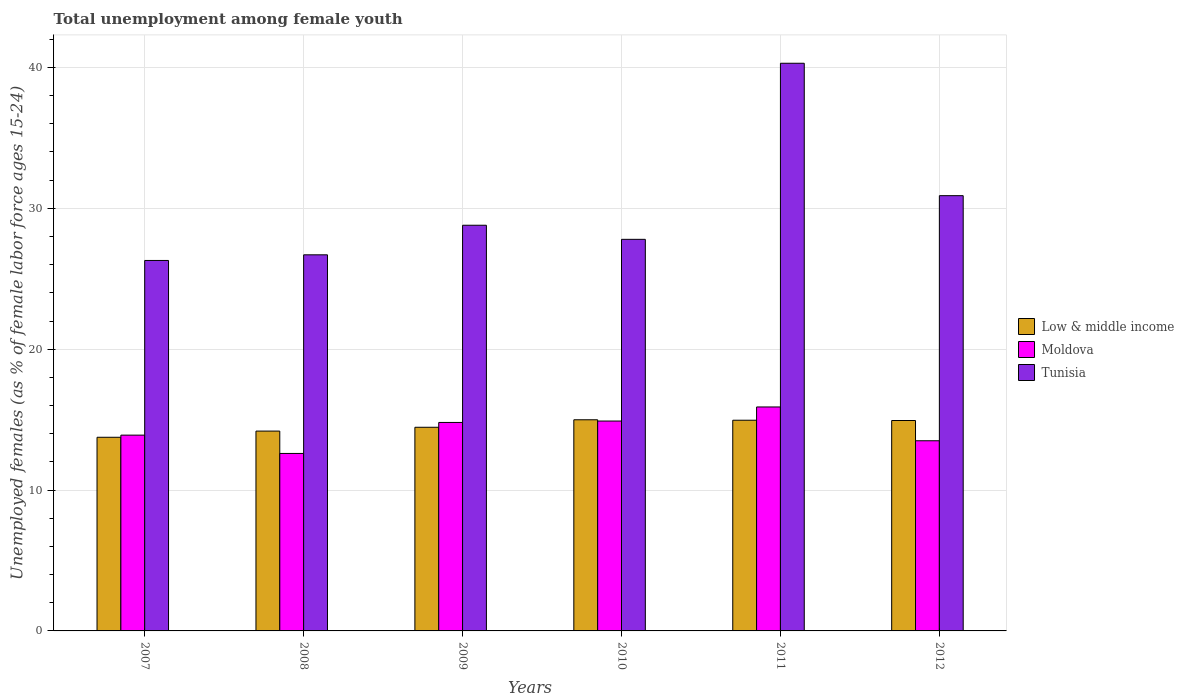How many different coloured bars are there?
Give a very brief answer. 3. How many bars are there on the 6th tick from the right?
Give a very brief answer. 3. What is the percentage of unemployed females in in Low & middle income in 2007?
Provide a short and direct response. 13.75. Across all years, what is the maximum percentage of unemployed females in in Tunisia?
Provide a short and direct response. 40.3. Across all years, what is the minimum percentage of unemployed females in in Low & middle income?
Offer a terse response. 13.75. In which year was the percentage of unemployed females in in Moldova maximum?
Offer a very short reply. 2011. What is the total percentage of unemployed females in in Low & middle income in the graph?
Provide a short and direct response. 87.28. What is the difference between the percentage of unemployed females in in Low & middle income in 2008 and that in 2010?
Keep it short and to the point. -0.8. What is the difference between the percentage of unemployed females in in Moldova in 2011 and the percentage of unemployed females in in Low & middle income in 2010?
Keep it short and to the point. 0.91. What is the average percentage of unemployed females in in Low & middle income per year?
Your answer should be compact. 14.55. In the year 2011, what is the difference between the percentage of unemployed females in in Low & middle income and percentage of unemployed females in in Tunisia?
Keep it short and to the point. -25.34. In how many years, is the percentage of unemployed females in in Low & middle income greater than 10 %?
Offer a terse response. 6. What is the ratio of the percentage of unemployed females in in Low & middle income in 2010 to that in 2011?
Give a very brief answer. 1. Is the difference between the percentage of unemployed females in in Low & middle income in 2009 and 2011 greater than the difference between the percentage of unemployed females in in Tunisia in 2009 and 2011?
Provide a succinct answer. Yes. What is the difference between the highest and the second highest percentage of unemployed females in in Tunisia?
Offer a terse response. 9.4. What is the difference between the highest and the lowest percentage of unemployed females in in Tunisia?
Offer a terse response. 14. In how many years, is the percentage of unemployed females in in Moldova greater than the average percentage of unemployed females in in Moldova taken over all years?
Provide a succinct answer. 3. Is the sum of the percentage of unemployed females in in Moldova in 2009 and 2011 greater than the maximum percentage of unemployed females in in Tunisia across all years?
Provide a succinct answer. No. What does the 3rd bar from the left in 2009 represents?
Keep it short and to the point. Tunisia. What does the 2nd bar from the right in 2012 represents?
Your answer should be very brief. Moldova. Is it the case that in every year, the sum of the percentage of unemployed females in in Low & middle income and percentage of unemployed females in in Tunisia is greater than the percentage of unemployed females in in Moldova?
Your response must be concise. Yes. How many years are there in the graph?
Make the answer very short. 6. Does the graph contain any zero values?
Offer a very short reply. No. Does the graph contain grids?
Offer a very short reply. Yes. What is the title of the graph?
Give a very brief answer. Total unemployment among female youth. Does "High income" appear as one of the legend labels in the graph?
Provide a succinct answer. No. What is the label or title of the X-axis?
Make the answer very short. Years. What is the label or title of the Y-axis?
Offer a terse response. Unemployed females (as % of female labor force ages 15-24). What is the Unemployed females (as % of female labor force ages 15-24) of Low & middle income in 2007?
Offer a terse response. 13.75. What is the Unemployed females (as % of female labor force ages 15-24) of Moldova in 2007?
Your answer should be very brief. 13.9. What is the Unemployed females (as % of female labor force ages 15-24) in Tunisia in 2007?
Make the answer very short. 26.3. What is the Unemployed females (as % of female labor force ages 15-24) of Low & middle income in 2008?
Your answer should be very brief. 14.19. What is the Unemployed females (as % of female labor force ages 15-24) of Moldova in 2008?
Provide a short and direct response. 12.6. What is the Unemployed females (as % of female labor force ages 15-24) in Tunisia in 2008?
Give a very brief answer. 26.7. What is the Unemployed females (as % of female labor force ages 15-24) in Low & middle income in 2009?
Your answer should be very brief. 14.46. What is the Unemployed females (as % of female labor force ages 15-24) of Moldova in 2009?
Your response must be concise. 14.8. What is the Unemployed females (as % of female labor force ages 15-24) in Tunisia in 2009?
Provide a short and direct response. 28.8. What is the Unemployed females (as % of female labor force ages 15-24) of Low & middle income in 2010?
Provide a succinct answer. 14.99. What is the Unemployed females (as % of female labor force ages 15-24) in Moldova in 2010?
Give a very brief answer. 14.9. What is the Unemployed females (as % of female labor force ages 15-24) in Tunisia in 2010?
Your answer should be compact. 27.8. What is the Unemployed females (as % of female labor force ages 15-24) in Low & middle income in 2011?
Provide a short and direct response. 14.96. What is the Unemployed females (as % of female labor force ages 15-24) in Moldova in 2011?
Keep it short and to the point. 15.9. What is the Unemployed females (as % of female labor force ages 15-24) in Tunisia in 2011?
Give a very brief answer. 40.3. What is the Unemployed females (as % of female labor force ages 15-24) of Low & middle income in 2012?
Your response must be concise. 14.94. What is the Unemployed females (as % of female labor force ages 15-24) of Moldova in 2012?
Provide a short and direct response. 13.5. What is the Unemployed females (as % of female labor force ages 15-24) of Tunisia in 2012?
Offer a terse response. 30.9. Across all years, what is the maximum Unemployed females (as % of female labor force ages 15-24) of Low & middle income?
Ensure brevity in your answer.  14.99. Across all years, what is the maximum Unemployed females (as % of female labor force ages 15-24) of Moldova?
Make the answer very short. 15.9. Across all years, what is the maximum Unemployed females (as % of female labor force ages 15-24) of Tunisia?
Your response must be concise. 40.3. Across all years, what is the minimum Unemployed females (as % of female labor force ages 15-24) in Low & middle income?
Your response must be concise. 13.75. Across all years, what is the minimum Unemployed females (as % of female labor force ages 15-24) in Moldova?
Make the answer very short. 12.6. Across all years, what is the minimum Unemployed females (as % of female labor force ages 15-24) of Tunisia?
Your response must be concise. 26.3. What is the total Unemployed females (as % of female labor force ages 15-24) of Low & middle income in the graph?
Give a very brief answer. 87.28. What is the total Unemployed females (as % of female labor force ages 15-24) of Moldova in the graph?
Offer a terse response. 85.6. What is the total Unemployed females (as % of female labor force ages 15-24) of Tunisia in the graph?
Offer a terse response. 180.8. What is the difference between the Unemployed females (as % of female labor force ages 15-24) in Low & middle income in 2007 and that in 2008?
Give a very brief answer. -0.44. What is the difference between the Unemployed females (as % of female labor force ages 15-24) of Low & middle income in 2007 and that in 2009?
Keep it short and to the point. -0.71. What is the difference between the Unemployed females (as % of female labor force ages 15-24) in Moldova in 2007 and that in 2009?
Provide a succinct answer. -0.9. What is the difference between the Unemployed females (as % of female labor force ages 15-24) in Tunisia in 2007 and that in 2009?
Your response must be concise. -2.5. What is the difference between the Unemployed females (as % of female labor force ages 15-24) of Low & middle income in 2007 and that in 2010?
Provide a succinct answer. -1.24. What is the difference between the Unemployed females (as % of female labor force ages 15-24) in Moldova in 2007 and that in 2010?
Offer a terse response. -1. What is the difference between the Unemployed females (as % of female labor force ages 15-24) in Low & middle income in 2007 and that in 2011?
Keep it short and to the point. -1.21. What is the difference between the Unemployed females (as % of female labor force ages 15-24) in Moldova in 2007 and that in 2011?
Your answer should be very brief. -2. What is the difference between the Unemployed females (as % of female labor force ages 15-24) in Low & middle income in 2007 and that in 2012?
Your answer should be very brief. -1.19. What is the difference between the Unemployed females (as % of female labor force ages 15-24) of Tunisia in 2007 and that in 2012?
Make the answer very short. -4.6. What is the difference between the Unemployed females (as % of female labor force ages 15-24) of Low & middle income in 2008 and that in 2009?
Provide a succinct answer. -0.27. What is the difference between the Unemployed females (as % of female labor force ages 15-24) in Moldova in 2008 and that in 2009?
Provide a short and direct response. -2.2. What is the difference between the Unemployed females (as % of female labor force ages 15-24) in Tunisia in 2008 and that in 2009?
Provide a succinct answer. -2.1. What is the difference between the Unemployed females (as % of female labor force ages 15-24) of Low & middle income in 2008 and that in 2010?
Your response must be concise. -0.8. What is the difference between the Unemployed females (as % of female labor force ages 15-24) in Moldova in 2008 and that in 2010?
Your answer should be very brief. -2.3. What is the difference between the Unemployed females (as % of female labor force ages 15-24) of Low & middle income in 2008 and that in 2011?
Give a very brief answer. -0.77. What is the difference between the Unemployed females (as % of female labor force ages 15-24) of Moldova in 2008 and that in 2011?
Keep it short and to the point. -3.3. What is the difference between the Unemployed females (as % of female labor force ages 15-24) in Tunisia in 2008 and that in 2011?
Your answer should be very brief. -13.6. What is the difference between the Unemployed females (as % of female labor force ages 15-24) of Low & middle income in 2008 and that in 2012?
Your response must be concise. -0.75. What is the difference between the Unemployed females (as % of female labor force ages 15-24) in Low & middle income in 2009 and that in 2010?
Your response must be concise. -0.53. What is the difference between the Unemployed females (as % of female labor force ages 15-24) of Moldova in 2009 and that in 2010?
Provide a succinct answer. -0.1. What is the difference between the Unemployed females (as % of female labor force ages 15-24) of Low & middle income in 2009 and that in 2011?
Provide a short and direct response. -0.5. What is the difference between the Unemployed females (as % of female labor force ages 15-24) of Moldova in 2009 and that in 2011?
Your answer should be very brief. -1.1. What is the difference between the Unemployed females (as % of female labor force ages 15-24) of Low & middle income in 2009 and that in 2012?
Your response must be concise. -0.48. What is the difference between the Unemployed females (as % of female labor force ages 15-24) of Tunisia in 2009 and that in 2012?
Keep it short and to the point. -2.1. What is the difference between the Unemployed females (as % of female labor force ages 15-24) in Low & middle income in 2010 and that in 2011?
Your answer should be compact. 0.03. What is the difference between the Unemployed females (as % of female labor force ages 15-24) in Moldova in 2010 and that in 2011?
Provide a succinct answer. -1. What is the difference between the Unemployed females (as % of female labor force ages 15-24) of Tunisia in 2010 and that in 2011?
Provide a succinct answer. -12.5. What is the difference between the Unemployed females (as % of female labor force ages 15-24) in Low & middle income in 2010 and that in 2012?
Keep it short and to the point. 0.05. What is the difference between the Unemployed females (as % of female labor force ages 15-24) of Low & middle income in 2011 and that in 2012?
Provide a succinct answer. 0.02. What is the difference between the Unemployed females (as % of female labor force ages 15-24) in Moldova in 2011 and that in 2012?
Your answer should be very brief. 2.4. What is the difference between the Unemployed females (as % of female labor force ages 15-24) of Tunisia in 2011 and that in 2012?
Your response must be concise. 9.4. What is the difference between the Unemployed females (as % of female labor force ages 15-24) of Low & middle income in 2007 and the Unemployed females (as % of female labor force ages 15-24) of Moldova in 2008?
Your response must be concise. 1.15. What is the difference between the Unemployed females (as % of female labor force ages 15-24) in Low & middle income in 2007 and the Unemployed females (as % of female labor force ages 15-24) in Tunisia in 2008?
Give a very brief answer. -12.95. What is the difference between the Unemployed females (as % of female labor force ages 15-24) of Moldova in 2007 and the Unemployed females (as % of female labor force ages 15-24) of Tunisia in 2008?
Your answer should be compact. -12.8. What is the difference between the Unemployed females (as % of female labor force ages 15-24) of Low & middle income in 2007 and the Unemployed females (as % of female labor force ages 15-24) of Moldova in 2009?
Provide a short and direct response. -1.05. What is the difference between the Unemployed females (as % of female labor force ages 15-24) of Low & middle income in 2007 and the Unemployed females (as % of female labor force ages 15-24) of Tunisia in 2009?
Ensure brevity in your answer.  -15.05. What is the difference between the Unemployed females (as % of female labor force ages 15-24) in Moldova in 2007 and the Unemployed females (as % of female labor force ages 15-24) in Tunisia in 2009?
Your response must be concise. -14.9. What is the difference between the Unemployed females (as % of female labor force ages 15-24) of Low & middle income in 2007 and the Unemployed females (as % of female labor force ages 15-24) of Moldova in 2010?
Give a very brief answer. -1.15. What is the difference between the Unemployed females (as % of female labor force ages 15-24) of Low & middle income in 2007 and the Unemployed females (as % of female labor force ages 15-24) of Tunisia in 2010?
Ensure brevity in your answer.  -14.05. What is the difference between the Unemployed females (as % of female labor force ages 15-24) of Low & middle income in 2007 and the Unemployed females (as % of female labor force ages 15-24) of Moldova in 2011?
Provide a succinct answer. -2.15. What is the difference between the Unemployed females (as % of female labor force ages 15-24) in Low & middle income in 2007 and the Unemployed females (as % of female labor force ages 15-24) in Tunisia in 2011?
Give a very brief answer. -26.55. What is the difference between the Unemployed females (as % of female labor force ages 15-24) of Moldova in 2007 and the Unemployed females (as % of female labor force ages 15-24) of Tunisia in 2011?
Provide a succinct answer. -26.4. What is the difference between the Unemployed females (as % of female labor force ages 15-24) in Low & middle income in 2007 and the Unemployed females (as % of female labor force ages 15-24) in Moldova in 2012?
Keep it short and to the point. 0.25. What is the difference between the Unemployed females (as % of female labor force ages 15-24) in Low & middle income in 2007 and the Unemployed females (as % of female labor force ages 15-24) in Tunisia in 2012?
Offer a very short reply. -17.15. What is the difference between the Unemployed females (as % of female labor force ages 15-24) of Moldova in 2007 and the Unemployed females (as % of female labor force ages 15-24) of Tunisia in 2012?
Your answer should be compact. -17. What is the difference between the Unemployed females (as % of female labor force ages 15-24) of Low & middle income in 2008 and the Unemployed females (as % of female labor force ages 15-24) of Moldova in 2009?
Give a very brief answer. -0.61. What is the difference between the Unemployed females (as % of female labor force ages 15-24) of Low & middle income in 2008 and the Unemployed females (as % of female labor force ages 15-24) of Tunisia in 2009?
Make the answer very short. -14.61. What is the difference between the Unemployed females (as % of female labor force ages 15-24) of Moldova in 2008 and the Unemployed females (as % of female labor force ages 15-24) of Tunisia in 2009?
Your answer should be compact. -16.2. What is the difference between the Unemployed females (as % of female labor force ages 15-24) in Low & middle income in 2008 and the Unemployed females (as % of female labor force ages 15-24) in Moldova in 2010?
Make the answer very short. -0.71. What is the difference between the Unemployed females (as % of female labor force ages 15-24) in Low & middle income in 2008 and the Unemployed females (as % of female labor force ages 15-24) in Tunisia in 2010?
Offer a terse response. -13.61. What is the difference between the Unemployed females (as % of female labor force ages 15-24) of Moldova in 2008 and the Unemployed females (as % of female labor force ages 15-24) of Tunisia in 2010?
Your answer should be compact. -15.2. What is the difference between the Unemployed females (as % of female labor force ages 15-24) of Low & middle income in 2008 and the Unemployed females (as % of female labor force ages 15-24) of Moldova in 2011?
Your answer should be compact. -1.71. What is the difference between the Unemployed females (as % of female labor force ages 15-24) of Low & middle income in 2008 and the Unemployed females (as % of female labor force ages 15-24) of Tunisia in 2011?
Keep it short and to the point. -26.11. What is the difference between the Unemployed females (as % of female labor force ages 15-24) in Moldova in 2008 and the Unemployed females (as % of female labor force ages 15-24) in Tunisia in 2011?
Your answer should be compact. -27.7. What is the difference between the Unemployed females (as % of female labor force ages 15-24) in Low & middle income in 2008 and the Unemployed females (as % of female labor force ages 15-24) in Moldova in 2012?
Provide a succinct answer. 0.69. What is the difference between the Unemployed females (as % of female labor force ages 15-24) in Low & middle income in 2008 and the Unemployed females (as % of female labor force ages 15-24) in Tunisia in 2012?
Make the answer very short. -16.71. What is the difference between the Unemployed females (as % of female labor force ages 15-24) in Moldova in 2008 and the Unemployed females (as % of female labor force ages 15-24) in Tunisia in 2012?
Provide a succinct answer. -18.3. What is the difference between the Unemployed females (as % of female labor force ages 15-24) in Low & middle income in 2009 and the Unemployed females (as % of female labor force ages 15-24) in Moldova in 2010?
Give a very brief answer. -0.44. What is the difference between the Unemployed females (as % of female labor force ages 15-24) in Low & middle income in 2009 and the Unemployed females (as % of female labor force ages 15-24) in Tunisia in 2010?
Keep it short and to the point. -13.34. What is the difference between the Unemployed females (as % of female labor force ages 15-24) of Low & middle income in 2009 and the Unemployed females (as % of female labor force ages 15-24) of Moldova in 2011?
Your answer should be compact. -1.44. What is the difference between the Unemployed females (as % of female labor force ages 15-24) of Low & middle income in 2009 and the Unemployed females (as % of female labor force ages 15-24) of Tunisia in 2011?
Offer a terse response. -25.84. What is the difference between the Unemployed females (as % of female labor force ages 15-24) of Moldova in 2009 and the Unemployed females (as % of female labor force ages 15-24) of Tunisia in 2011?
Your response must be concise. -25.5. What is the difference between the Unemployed females (as % of female labor force ages 15-24) of Low & middle income in 2009 and the Unemployed females (as % of female labor force ages 15-24) of Moldova in 2012?
Ensure brevity in your answer.  0.96. What is the difference between the Unemployed females (as % of female labor force ages 15-24) of Low & middle income in 2009 and the Unemployed females (as % of female labor force ages 15-24) of Tunisia in 2012?
Provide a short and direct response. -16.44. What is the difference between the Unemployed females (as % of female labor force ages 15-24) in Moldova in 2009 and the Unemployed females (as % of female labor force ages 15-24) in Tunisia in 2012?
Your answer should be compact. -16.1. What is the difference between the Unemployed females (as % of female labor force ages 15-24) in Low & middle income in 2010 and the Unemployed females (as % of female labor force ages 15-24) in Moldova in 2011?
Give a very brief answer. -0.91. What is the difference between the Unemployed females (as % of female labor force ages 15-24) in Low & middle income in 2010 and the Unemployed females (as % of female labor force ages 15-24) in Tunisia in 2011?
Your answer should be compact. -25.31. What is the difference between the Unemployed females (as % of female labor force ages 15-24) of Moldova in 2010 and the Unemployed females (as % of female labor force ages 15-24) of Tunisia in 2011?
Your answer should be very brief. -25.4. What is the difference between the Unemployed females (as % of female labor force ages 15-24) of Low & middle income in 2010 and the Unemployed females (as % of female labor force ages 15-24) of Moldova in 2012?
Make the answer very short. 1.49. What is the difference between the Unemployed females (as % of female labor force ages 15-24) of Low & middle income in 2010 and the Unemployed females (as % of female labor force ages 15-24) of Tunisia in 2012?
Make the answer very short. -15.91. What is the difference between the Unemployed females (as % of female labor force ages 15-24) in Moldova in 2010 and the Unemployed females (as % of female labor force ages 15-24) in Tunisia in 2012?
Your answer should be very brief. -16. What is the difference between the Unemployed females (as % of female labor force ages 15-24) of Low & middle income in 2011 and the Unemployed females (as % of female labor force ages 15-24) of Moldova in 2012?
Give a very brief answer. 1.46. What is the difference between the Unemployed females (as % of female labor force ages 15-24) of Low & middle income in 2011 and the Unemployed females (as % of female labor force ages 15-24) of Tunisia in 2012?
Keep it short and to the point. -15.94. What is the difference between the Unemployed females (as % of female labor force ages 15-24) of Moldova in 2011 and the Unemployed females (as % of female labor force ages 15-24) of Tunisia in 2012?
Make the answer very short. -15. What is the average Unemployed females (as % of female labor force ages 15-24) in Low & middle income per year?
Your answer should be compact. 14.55. What is the average Unemployed females (as % of female labor force ages 15-24) in Moldova per year?
Make the answer very short. 14.27. What is the average Unemployed females (as % of female labor force ages 15-24) in Tunisia per year?
Offer a terse response. 30.13. In the year 2007, what is the difference between the Unemployed females (as % of female labor force ages 15-24) in Low & middle income and Unemployed females (as % of female labor force ages 15-24) in Moldova?
Keep it short and to the point. -0.15. In the year 2007, what is the difference between the Unemployed females (as % of female labor force ages 15-24) of Low & middle income and Unemployed females (as % of female labor force ages 15-24) of Tunisia?
Provide a short and direct response. -12.55. In the year 2008, what is the difference between the Unemployed females (as % of female labor force ages 15-24) in Low & middle income and Unemployed females (as % of female labor force ages 15-24) in Moldova?
Your answer should be compact. 1.59. In the year 2008, what is the difference between the Unemployed females (as % of female labor force ages 15-24) of Low & middle income and Unemployed females (as % of female labor force ages 15-24) of Tunisia?
Make the answer very short. -12.51. In the year 2008, what is the difference between the Unemployed females (as % of female labor force ages 15-24) of Moldova and Unemployed females (as % of female labor force ages 15-24) of Tunisia?
Offer a very short reply. -14.1. In the year 2009, what is the difference between the Unemployed females (as % of female labor force ages 15-24) in Low & middle income and Unemployed females (as % of female labor force ages 15-24) in Moldova?
Your answer should be compact. -0.34. In the year 2009, what is the difference between the Unemployed females (as % of female labor force ages 15-24) in Low & middle income and Unemployed females (as % of female labor force ages 15-24) in Tunisia?
Provide a short and direct response. -14.34. In the year 2009, what is the difference between the Unemployed females (as % of female labor force ages 15-24) in Moldova and Unemployed females (as % of female labor force ages 15-24) in Tunisia?
Provide a succinct answer. -14. In the year 2010, what is the difference between the Unemployed females (as % of female labor force ages 15-24) in Low & middle income and Unemployed females (as % of female labor force ages 15-24) in Moldova?
Ensure brevity in your answer.  0.09. In the year 2010, what is the difference between the Unemployed females (as % of female labor force ages 15-24) of Low & middle income and Unemployed females (as % of female labor force ages 15-24) of Tunisia?
Your answer should be very brief. -12.81. In the year 2010, what is the difference between the Unemployed females (as % of female labor force ages 15-24) in Moldova and Unemployed females (as % of female labor force ages 15-24) in Tunisia?
Give a very brief answer. -12.9. In the year 2011, what is the difference between the Unemployed females (as % of female labor force ages 15-24) of Low & middle income and Unemployed females (as % of female labor force ages 15-24) of Moldova?
Provide a succinct answer. -0.94. In the year 2011, what is the difference between the Unemployed females (as % of female labor force ages 15-24) in Low & middle income and Unemployed females (as % of female labor force ages 15-24) in Tunisia?
Ensure brevity in your answer.  -25.34. In the year 2011, what is the difference between the Unemployed females (as % of female labor force ages 15-24) of Moldova and Unemployed females (as % of female labor force ages 15-24) of Tunisia?
Keep it short and to the point. -24.4. In the year 2012, what is the difference between the Unemployed females (as % of female labor force ages 15-24) in Low & middle income and Unemployed females (as % of female labor force ages 15-24) in Moldova?
Provide a succinct answer. 1.44. In the year 2012, what is the difference between the Unemployed females (as % of female labor force ages 15-24) of Low & middle income and Unemployed females (as % of female labor force ages 15-24) of Tunisia?
Your response must be concise. -15.96. In the year 2012, what is the difference between the Unemployed females (as % of female labor force ages 15-24) of Moldova and Unemployed females (as % of female labor force ages 15-24) of Tunisia?
Your response must be concise. -17.4. What is the ratio of the Unemployed females (as % of female labor force ages 15-24) in Low & middle income in 2007 to that in 2008?
Offer a very short reply. 0.97. What is the ratio of the Unemployed females (as % of female labor force ages 15-24) in Moldova in 2007 to that in 2008?
Keep it short and to the point. 1.1. What is the ratio of the Unemployed females (as % of female labor force ages 15-24) of Low & middle income in 2007 to that in 2009?
Make the answer very short. 0.95. What is the ratio of the Unemployed females (as % of female labor force ages 15-24) of Moldova in 2007 to that in 2009?
Your answer should be very brief. 0.94. What is the ratio of the Unemployed females (as % of female labor force ages 15-24) in Tunisia in 2007 to that in 2009?
Offer a terse response. 0.91. What is the ratio of the Unemployed females (as % of female labor force ages 15-24) in Low & middle income in 2007 to that in 2010?
Your response must be concise. 0.92. What is the ratio of the Unemployed females (as % of female labor force ages 15-24) in Moldova in 2007 to that in 2010?
Your response must be concise. 0.93. What is the ratio of the Unemployed females (as % of female labor force ages 15-24) in Tunisia in 2007 to that in 2010?
Make the answer very short. 0.95. What is the ratio of the Unemployed females (as % of female labor force ages 15-24) in Low & middle income in 2007 to that in 2011?
Give a very brief answer. 0.92. What is the ratio of the Unemployed females (as % of female labor force ages 15-24) of Moldova in 2007 to that in 2011?
Your answer should be compact. 0.87. What is the ratio of the Unemployed females (as % of female labor force ages 15-24) of Tunisia in 2007 to that in 2011?
Make the answer very short. 0.65. What is the ratio of the Unemployed females (as % of female labor force ages 15-24) in Low & middle income in 2007 to that in 2012?
Provide a short and direct response. 0.92. What is the ratio of the Unemployed females (as % of female labor force ages 15-24) in Moldova in 2007 to that in 2012?
Your answer should be compact. 1.03. What is the ratio of the Unemployed females (as % of female labor force ages 15-24) in Tunisia in 2007 to that in 2012?
Ensure brevity in your answer.  0.85. What is the ratio of the Unemployed females (as % of female labor force ages 15-24) in Low & middle income in 2008 to that in 2009?
Offer a very short reply. 0.98. What is the ratio of the Unemployed females (as % of female labor force ages 15-24) of Moldova in 2008 to that in 2009?
Provide a succinct answer. 0.85. What is the ratio of the Unemployed females (as % of female labor force ages 15-24) of Tunisia in 2008 to that in 2009?
Offer a terse response. 0.93. What is the ratio of the Unemployed females (as % of female labor force ages 15-24) of Low & middle income in 2008 to that in 2010?
Your answer should be compact. 0.95. What is the ratio of the Unemployed females (as % of female labor force ages 15-24) of Moldova in 2008 to that in 2010?
Offer a terse response. 0.85. What is the ratio of the Unemployed females (as % of female labor force ages 15-24) in Tunisia in 2008 to that in 2010?
Ensure brevity in your answer.  0.96. What is the ratio of the Unemployed females (as % of female labor force ages 15-24) in Low & middle income in 2008 to that in 2011?
Ensure brevity in your answer.  0.95. What is the ratio of the Unemployed females (as % of female labor force ages 15-24) in Moldova in 2008 to that in 2011?
Give a very brief answer. 0.79. What is the ratio of the Unemployed females (as % of female labor force ages 15-24) in Tunisia in 2008 to that in 2011?
Ensure brevity in your answer.  0.66. What is the ratio of the Unemployed females (as % of female labor force ages 15-24) in Low & middle income in 2008 to that in 2012?
Provide a short and direct response. 0.95. What is the ratio of the Unemployed females (as % of female labor force ages 15-24) in Moldova in 2008 to that in 2012?
Your answer should be very brief. 0.93. What is the ratio of the Unemployed females (as % of female labor force ages 15-24) of Tunisia in 2008 to that in 2012?
Ensure brevity in your answer.  0.86. What is the ratio of the Unemployed females (as % of female labor force ages 15-24) in Low & middle income in 2009 to that in 2010?
Offer a very short reply. 0.96. What is the ratio of the Unemployed females (as % of female labor force ages 15-24) in Moldova in 2009 to that in 2010?
Provide a succinct answer. 0.99. What is the ratio of the Unemployed females (as % of female labor force ages 15-24) of Tunisia in 2009 to that in 2010?
Keep it short and to the point. 1.04. What is the ratio of the Unemployed females (as % of female labor force ages 15-24) of Low & middle income in 2009 to that in 2011?
Provide a short and direct response. 0.97. What is the ratio of the Unemployed females (as % of female labor force ages 15-24) of Moldova in 2009 to that in 2011?
Ensure brevity in your answer.  0.93. What is the ratio of the Unemployed females (as % of female labor force ages 15-24) of Tunisia in 2009 to that in 2011?
Make the answer very short. 0.71. What is the ratio of the Unemployed females (as % of female labor force ages 15-24) in Low & middle income in 2009 to that in 2012?
Provide a short and direct response. 0.97. What is the ratio of the Unemployed females (as % of female labor force ages 15-24) of Moldova in 2009 to that in 2012?
Give a very brief answer. 1.1. What is the ratio of the Unemployed females (as % of female labor force ages 15-24) of Tunisia in 2009 to that in 2012?
Ensure brevity in your answer.  0.93. What is the ratio of the Unemployed females (as % of female labor force ages 15-24) of Low & middle income in 2010 to that in 2011?
Offer a very short reply. 1. What is the ratio of the Unemployed females (as % of female labor force ages 15-24) of Moldova in 2010 to that in 2011?
Offer a terse response. 0.94. What is the ratio of the Unemployed females (as % of female labor force ages 15-24) of Tunisia in 2010 to that in 2011?
Your response must be concise. 0.69. What is the ratio of the Unemployed females (as % of female labor force ages 15-24) in Low & middle income in 2010 to that in 2012?
Give a very brief answer. 1. What is the ratio of the Unemployed females (as % of female labor force ages 15-24) of Moldova in 2010 to that in 2012?
Offer a terse response. 1.1. What is the ratio of the Unemployed females (as % of female labor force ages 15-24) of Tunisia in 2010 to that in 2012?
Your response must be concise. 0.9. What is the ratio of the Unemployed females (as % of female labor force ages 15-24) in Moldova in 2011 to that in 2012?
Your response must be concise. 1.18. What is the ratio of the Unemployed females (as % of female labor force ages 15-24) in Tunisia in 2011 to that in 2012?
Give a very brief answer. 1.3. What is the difference between the highest and the second highest Unemployed females (as % of female labor force ages 15-24) in Low & middle income?
Keep it short and to the point. 0.03. What is the difference between the highest and the lowest Unemployed females (as % of female labor force ages 15-24) of Low & middle income?
Your answer should be compact. 1.24. What is the difference between the highest and the lowest Unemployed females (as % of female labor force ages 15-24) of Moldova?
Your answer should be very brief. 3.3. What is the difference between the highest and the lowest Unemployed females (as % of female labor force ages 15-24) in Tunisia?
Provide a succinct answer. 14. 